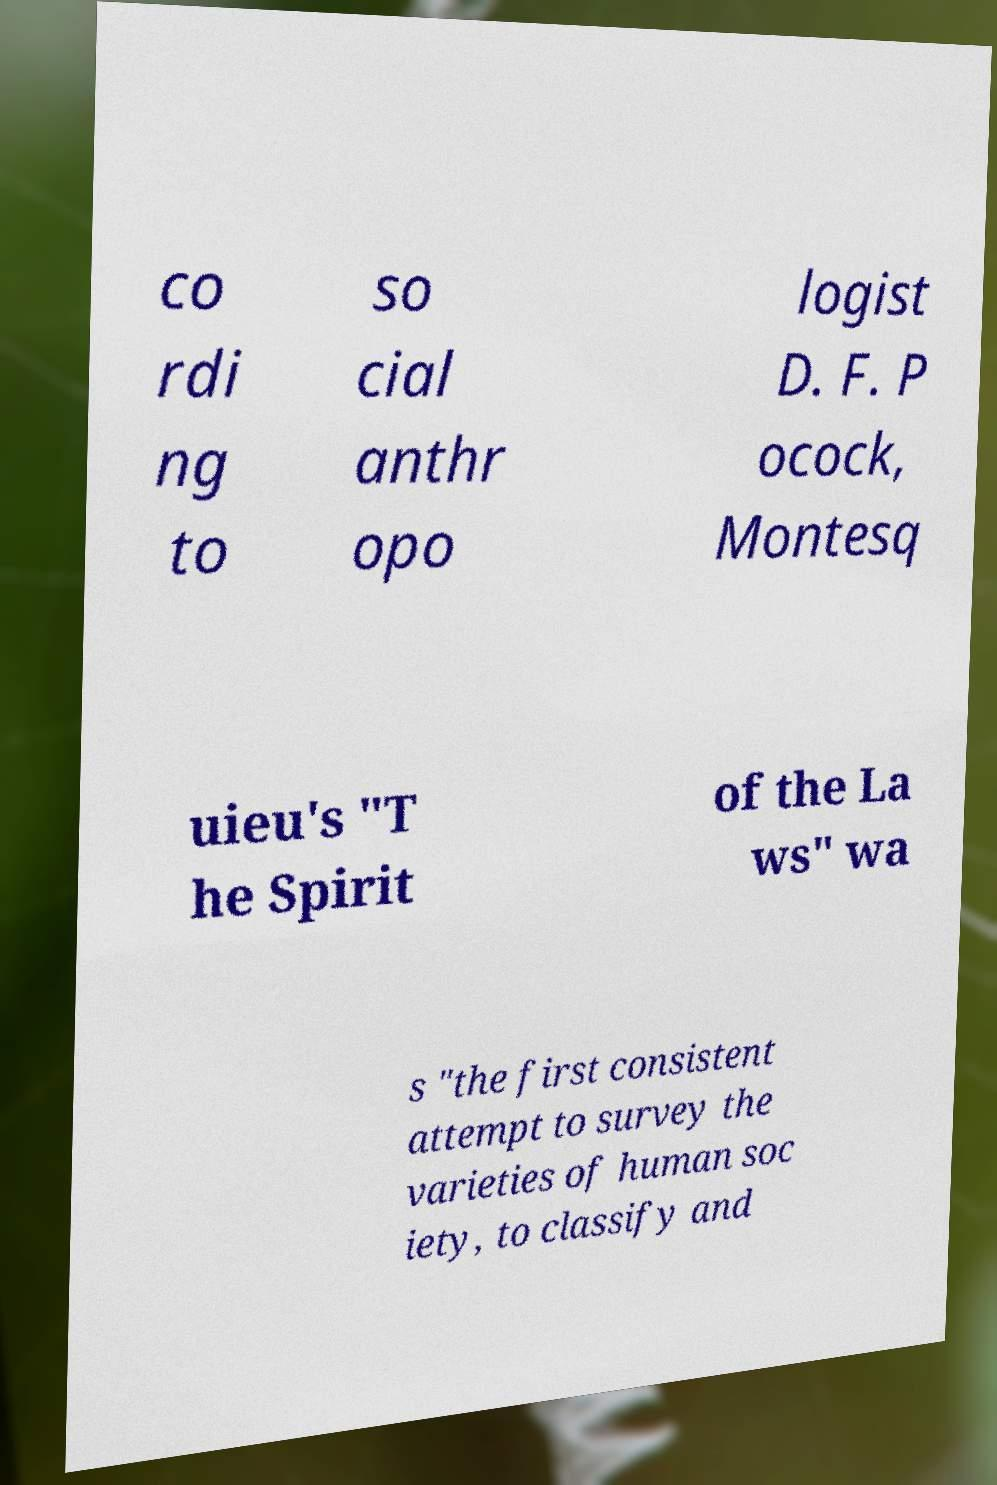Can you read and provide the text displayed in the image?This photo seems to have some interesting text. Can you extract and type it out for me? co rdi ng to so cial anthr opo logist D. F. P ocock, Montesq uieu's "T he Spirit of the La ws" wa s "the first consistent attempt to survey the varieties of human soc iety, to classify and 